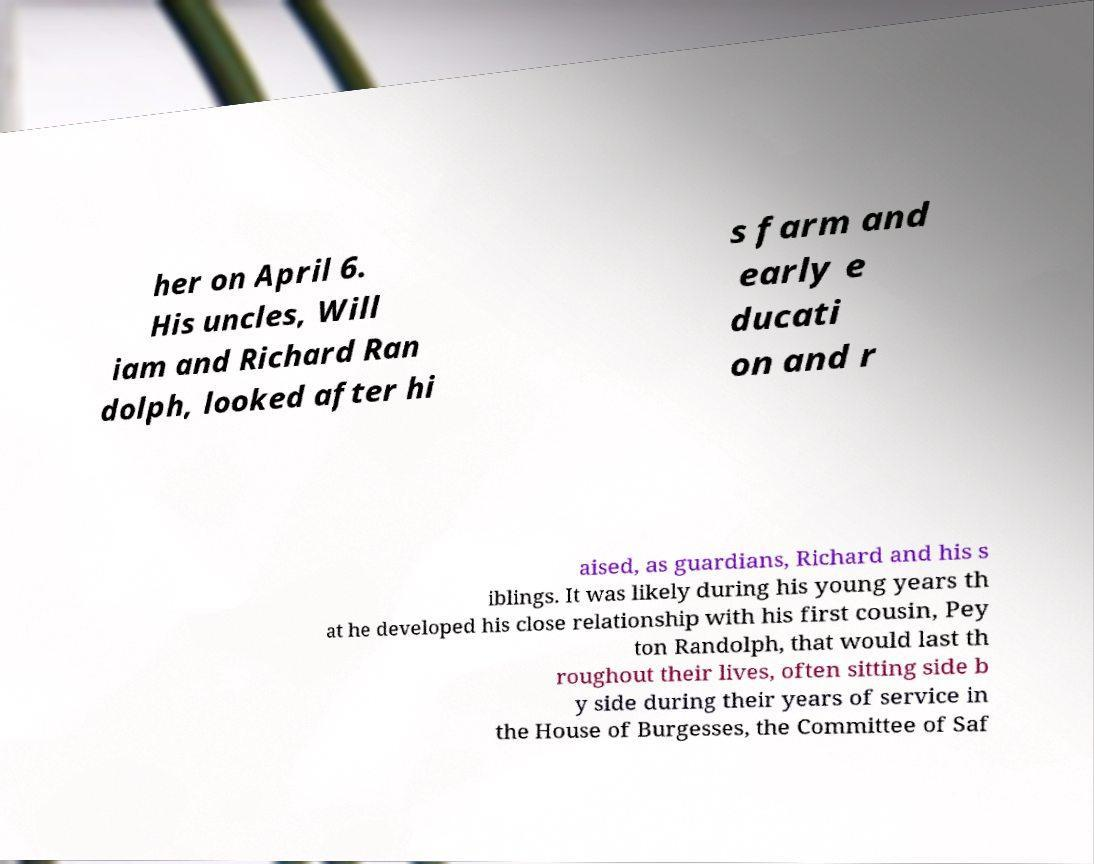Please read and relay the text visible in this image. What does it say? her on April 6. His uncles, Will iam and Richard Ran dolph, looked after hi s farm and early e ducati on and r aised, as guardians, Richard and his s iblings. It was likely during his young years th at he developed his close relationship with his first cousin, Pey ton Randolph, that would last th roughout their lives, often sitting side b y side during their years of service in the House of Burgesses, the Committee of Saf 